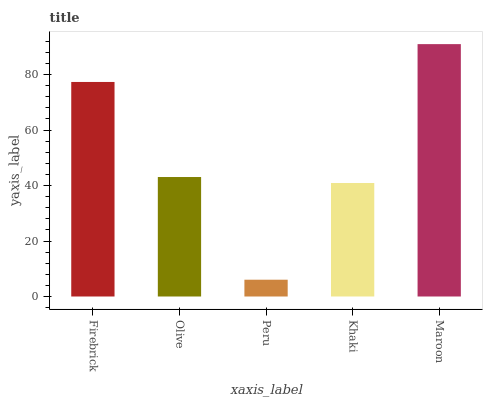Is Peru the minimum?
Answer yes or no. Yes. Is Maroon the maximum?
Answer yes or no. Yes. Is Olive the minimum?
Answer yes or no. No. Is Olive the maximum?
Answer yes or no. No. Is Firebrick greater than Olive?
Answer yes or no. Yes. Is Olive less than Firebrick?
Answer yes or no. Yes. Is Olive greater than Firebrick?
Answer yes or no. No. Is Firebrick less than Olive?
Answer yes or no. No. Is Olive the high median?
Answer yes or no. Yes. Is Olive the low median?
Answer yes or no. Yes. Is Khaki the high median?
Answer yes or no. No. Is Firebrick the low median?
Answer yes or no. No. 